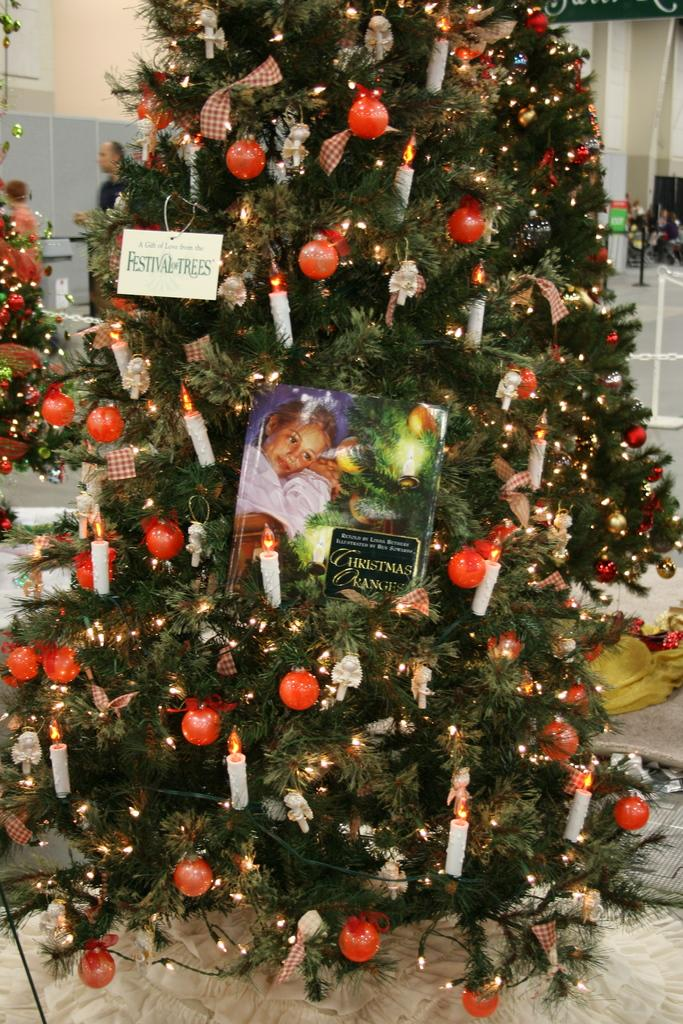What is the main object in the image? There is a Christmas tree in the image. How is the Christmas tree decorated? The Christmas tree has decorative items. What other objects can be seen in the image? There are candles, boards, and people visible in the image. What is in the background of the image? In the background, there are people, stands, a chain, more boards, the floor, and the wall. Can you see a kitten playing with an icicle in the image? No, there is no kitten or icicle present in the image. Is the person in the image taking a selfie? The provided facts do not mention any selfie or selfie-related activity in the image. 